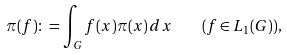<formula> <loc_0><loc_0><loc_500><loc_500>\pi ( f ) \colon = \int _ { G } f ( x ) \pi ( x ) \, d x \quad ( f \in L _ { 1 } ( G ) ) ,</formula> 